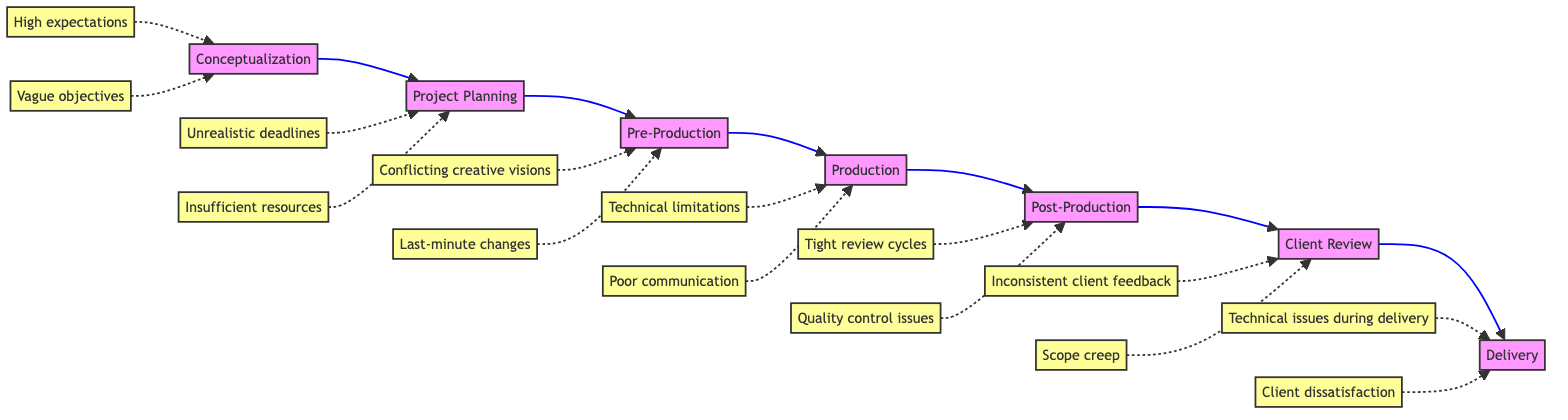What is the first step in the project management flow? The diagram shows that the first step is "Conceptualization," which is represented as the starting node on the left.
Answer: Conceptualization Which roles are involved in the Pre-Production step? Looking at the node under "Pre-Production," the key roles listed are "Storyboard Artist," "Scriptwriter," and "Concept Artist."
Answer: Storyboard Artist, Scriptwriter, Concept Artist How many challenges are associated with the Delivery step? The "Delivery" node indicates there are two challenges linked to it: "Technical issues during delivery" and "Client dissatisfaction," which can be counted.
Answer: 2 What is the last step in the project management flow? By following the flowchart from left to right, the final node is "Delivery," which indicates it is the last step in the process.
Answer: Delivery Which step comes directly after Post-Production? The flowchart indicates that the step following "Post-Production" is "Client Review," as the arrows show the sequential flow from one step to the next.
Answer: Client Review What are the challenges encountered in Production? The "Production" node has the challenges "Technical limitations" and "Poor communication" listed under it.
Answer: Technical limitations, Poor communication What is the relationship between Conceptualization and Project Planning? The diagram illustrates that "Conceptualization" leads directly to "Project Planning," which indicates a sequential relationship from the initial idea phase to planning.
Answer: Sequential relationship Which step has a challenge of 'Vague objectives'? Scanning through the challenges, "Vague objectives" is linked to the "Conceptualization" step, making it the correct association.
Answer: Conceptualization 